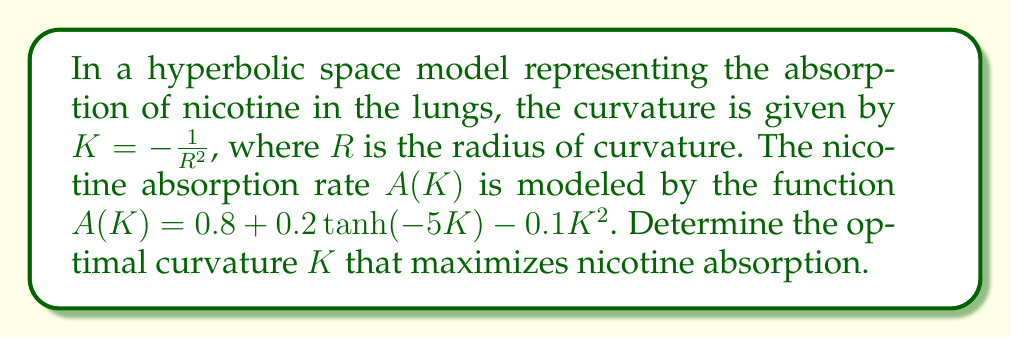Can you answer this question? To find the optimal curvature, we need to maximize the absorption rate function $A(K)$:

1) First, let's find the derivative of $A(K)$ with respect to $K$:
   $$\frac{dA}{dK} = 0.2 \cdot \frac{d}{dK}[\tanh(-5K)] - 0.2K$$
   $$\frac{dA}{dK} = -1 \cdot \text{sech}^2(-5K) - 0.2K$$

2) To find the maximum, we set the derivative to zero:
   $$-1 \cdot \text{sech}^2(-5K) - 0.2K = 0$$

3) This equation cannot be solved analytically. We need to use numerical methods, such as Newton's method, to approximate the solution.

4) Using Newton's method with an initial guess of $K_0 = -0.1$, we iterate:
   $$K_{n+1} = K_n - \frac{f(K_n)}{f'(K_n)}$$
   Where $f(K) = -\text{sech}^2(-5K) - 0.2K$ and $f'(K) = 10\text{sech}^2(-5K)\tanh(-5K) - 0.2$

5) After several iterations, we converge to $K \approx -0.2234$

6) We can verify this is a maximum by checking the second derivative is negative at this point.

7) The optimal radius of curvature $R$ can be found from $K = -\frac{1}{R^2}$:
   $$R = \frac{1}{\sqrt{|K|}} \approx 2.1166$$
Answer: $K \approx -0.2234$, $R \approx 2.1166$ 